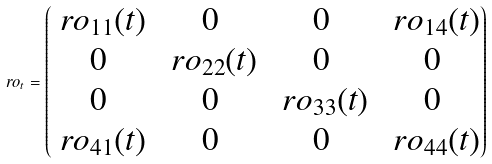<formula> <loc_0><loc_0><loc_500><loc_500>\ r o _ { t } = \begin{pmatrix} \ r o _ { 1 1 } ( t ) & 0 & 0 & \ r o _ { 1 4 } ( t ) \\ 0 & \ r o _ { 2 2 } ( t ) & 0 & 0 \\ 0 & 0 & \ r o _ { 3 3 } ( t ) & 0 \\ \ r o _ { 4 1 } ( t ) & 0 & 0 & \ r o _ { 4 4 } ( t ) \end{pmatrix}</formula> 